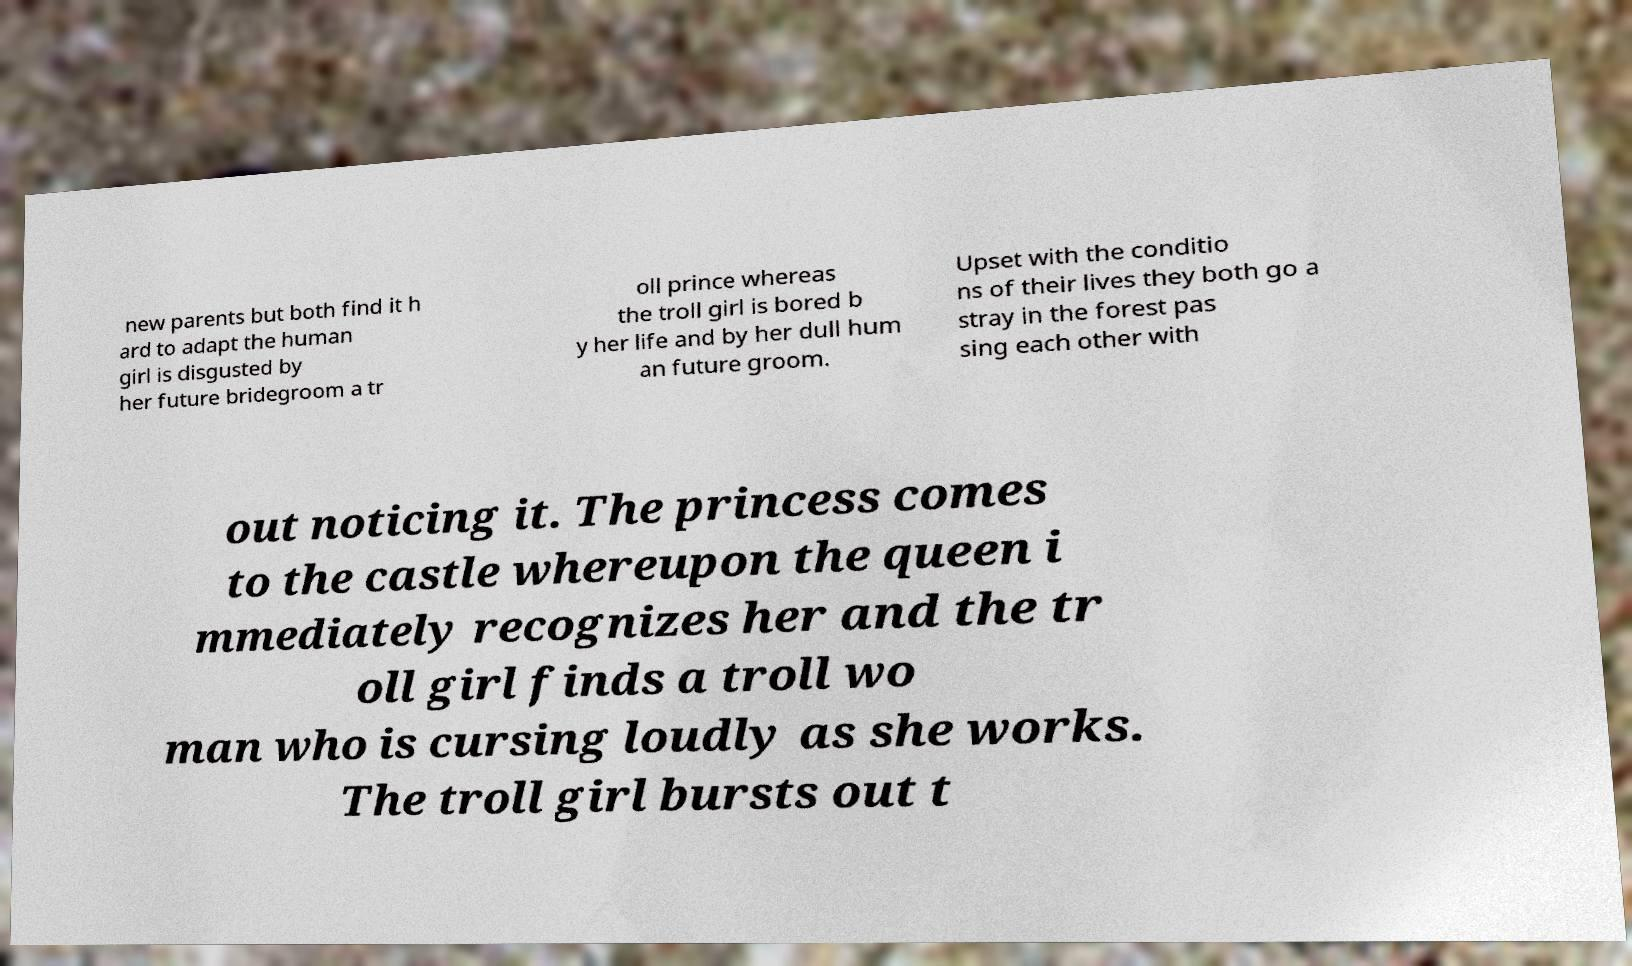Can you accurately transcribe the text from the provided image for me? new parents but both find it h ard to adapt the human girl is disgusted by her future bridegroom a tr oll prince whereas the troll girl is bored b y her life and by her dull hum an future groom. Upset with the conditio ns of their lives they both go a stray in the forest pas sing each other with out noticing it. The princess comes to the castle whereupon the queen i mmediately recognizes her and the tr oll girl finds a troll wo man who is cursing loudly as she works. The troll girl bursts out t 